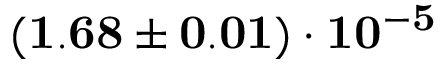<formula> <loc_0><loc_0><loc_500><loc_500>( 1 . 6 8 \pm 0 . 0 1 ) \cdot 1 0 ^ { - 5 }</formula> 